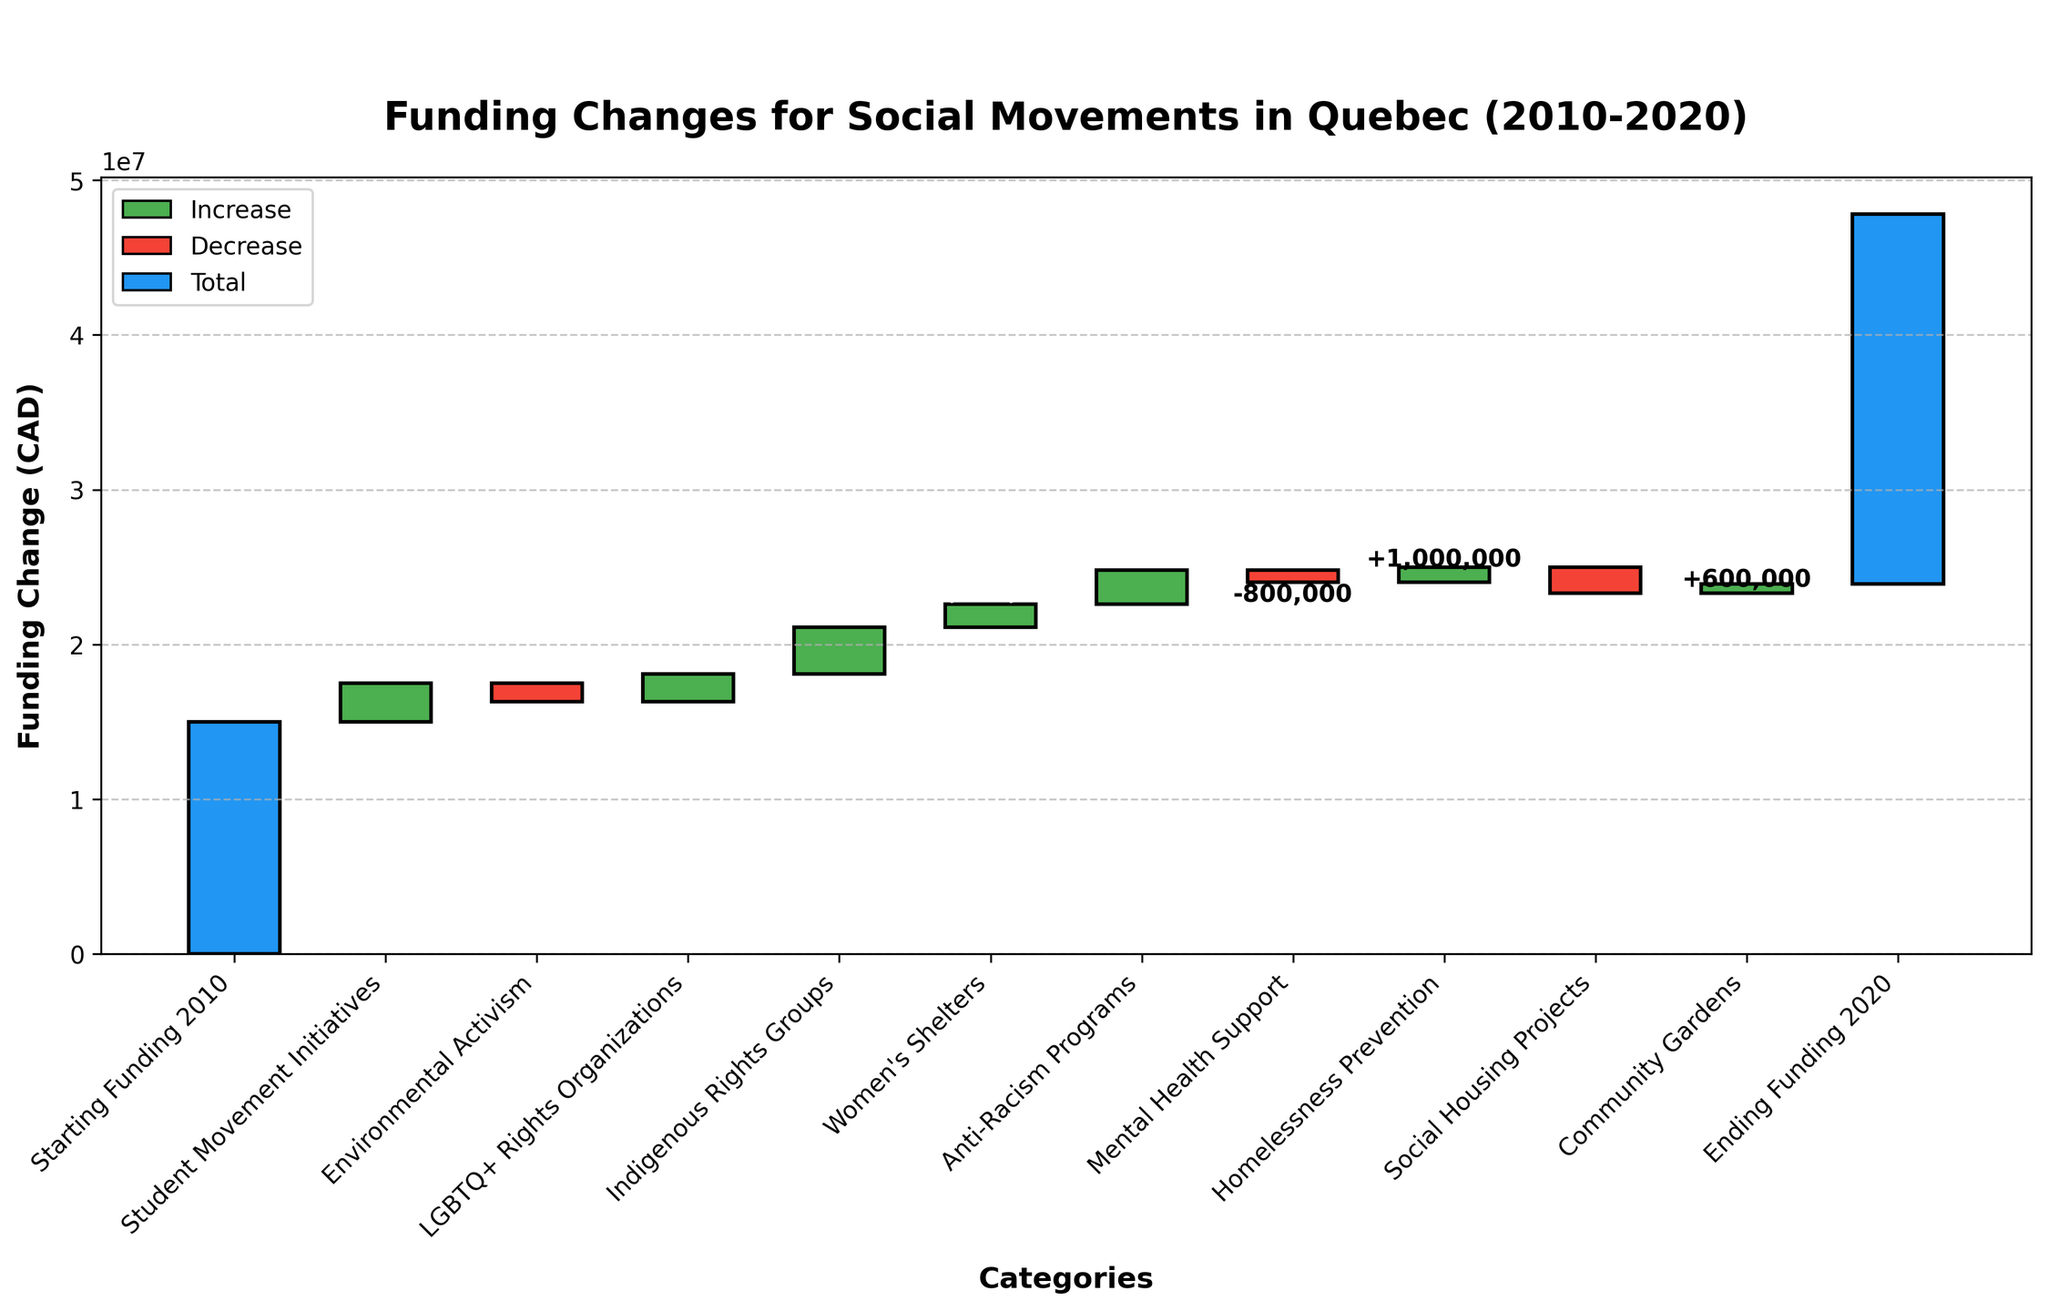How many categories are there in the figure? The figure has a total of 13 categories listed on the x-axis, ranging from "Starting Funding 2010" to "Ending Funding 2020".
Answer: 13 What is the title of the chart? The title of the chart is shown at the top and reads "Funding Changes for Social Movements in Quebec (2010-2020)".
Answer: Funding Changes for Social Movements in Quebec (2010-2020) Which category saw the largest increase in funding? To find the largest increase in funding, look for the tallest green bar (indicates a positive change). "Indigenous Rights Groups" has the tallest green bar with +3,000,000 CAD.
Answer: Indigenous Rights Groups Which category had the smallest decrease in funding? To find the smallest decrease in funding, compare the heights of the red bars (indicates negative change). "Mental Health Support" experienced a smaller decrease with -800,000 CAD compared to other negative changes.
Answer: Mental Health Support Calculate the net funding change for "Environmental Activism" and "Social Housing Projects". "Environmental Activism" decreased by 1,200,000 CAD and "Social Housing Projects" decreased by 1,700,000 CAD. The net funding change is -1,200,000 + (-1,700,000) = -2,900,000 CAD.
Answer: -2,900,000 CAD By how much did LGBTQ+ Rights Organizations' funding change? The bar for "LGBTQ+ Rights Organizations" indicates a positive change of 1,800,000 CAD.
Answer: 1,800,000 CAD What is the total increase in funding across all positive change categories? Sum the positive changes: 2,500,000 (Student Movement Initiatives) + 1,800,000 (LGBTQ+ Rights Organizations) + 3,000,000 (Indigenous Rights Groups) + 1,500,000 (Women's Shelters) + 2,200,000 (Anti-Racism Programs) + 1,000,000 (Homelessness Prevention) + 600,000 (Community Gardens) = 12,600,000 CAD.
Answer: 12,600,000 CAD What was the ending funding amount in 2020? The last bar labeled "Ending Funding 2020" depicts a total funding of 23,900,000 CAD.
Answer: 23,900,000 CAD How does the funding for Women's Shelters compare to Community Gardens? "Women's Shelters" saw an increase of 1,500,000 CAD, whereas "Community Gardens" had an increase of 600,000 CAD. Comparing these values, Women's Shelters had a larger increase.
Answer: Women's Shelters had a larger increase What is the range of funding changes shown in the chart (difference between largest increase and largest decrease)? The largest increase is 3,000,000 CAD (Indigenous Rights Groups) and the largest decrease is 1,700,000 CAD (Social Housing Projects). The range is 3,000,000 - (-1,700,000) = 4,700,000 CAD.
Answer: 4,700,000 CAD 